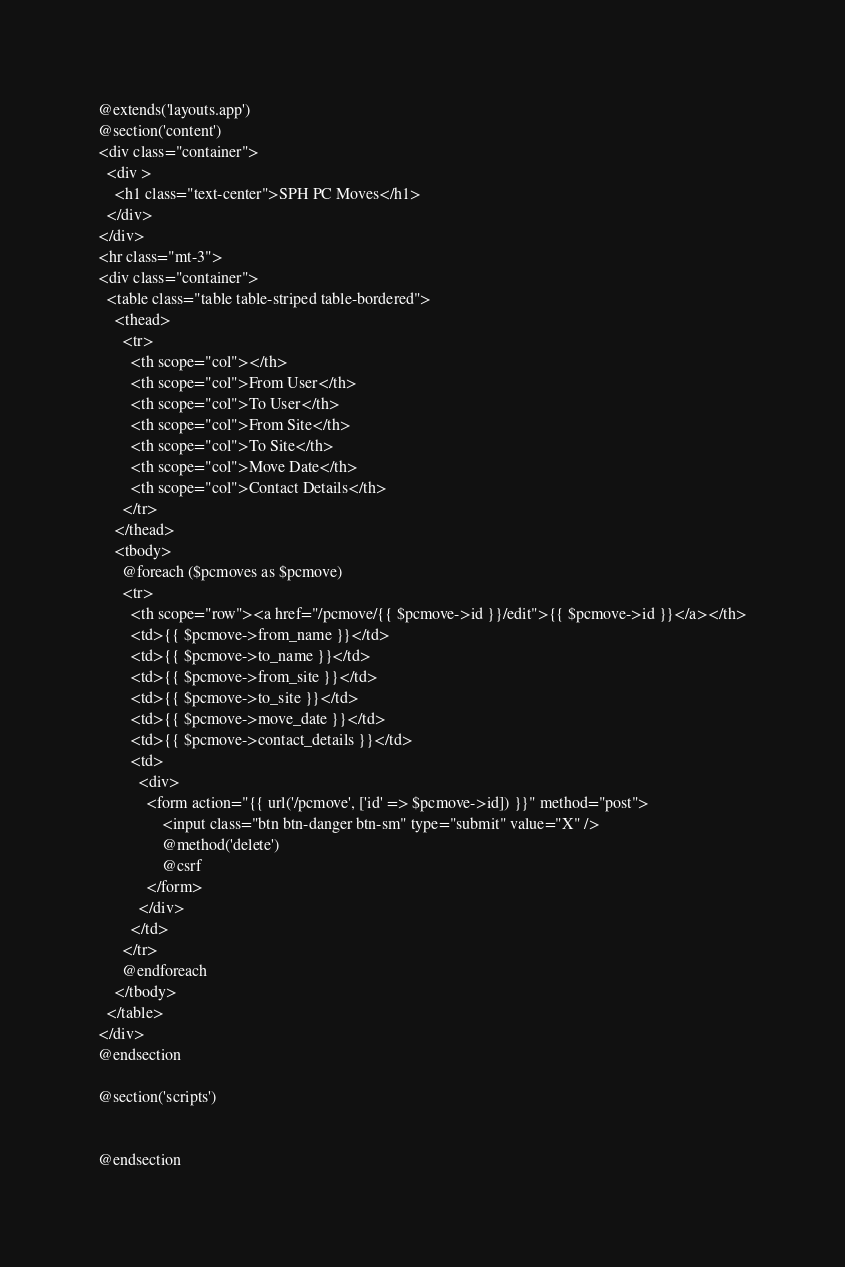Convert code to text. <code><loc_0><loc_0><loc_500><loc_500><_PHP_>@extends('layouts.app') 
@section('content')
<div class="container">
  <div >
    <h1 class="text-center">SPH PC Moves</h1>
  </div>
</div>
<hr class="mt-3">
<div class="container">
  <table class="table table-striped table-bordered">
    <thead>
      <tr>
        <th scope="col"></th>
        <th scope="col">From User</th>
        <th scope="col">To User</th>
        <th scope="col">From Site</th>
        <th scope="col">To Site</th>
        <th scope="col">Move Date</th>
        <th scope="col">Contact Details</th>
      </tr>
    </thead>
    <tbody>
      @foreach ($pcmoves as $pcmove)
      <tr>
        <th scope="row"><a href="/pcmove/{{ $pcmove->id }}/edit">{{ $pcmove->id }}</a></th>
        <td>{{ $pcmove->from_name }}</td>
        <td>{{ $pcmove->to_name }}</td>
        <td>{{ $pcmove->from_site }}</td>
        <td>{{ $pcmove->to_site }}</td>
        <td>{{ $pcmove->move_date }}</td>
        <td>{{ $pcmove->contact_details }}</td>
        <td>
          <div>
            <form action="{{ url('/pcmove', ['id' => $pcmove->id]) }}" method="post">
                <input class="btn btn-danger btn-sm" type="submit" value="X" />
                @method('delete')
                @csrf
            </form>
          </div>
        </td>
      </tr>
      @endforeach
    </tbody>
  </table>
</div>
@endsection

@section('scripts')


@endsection</code> 